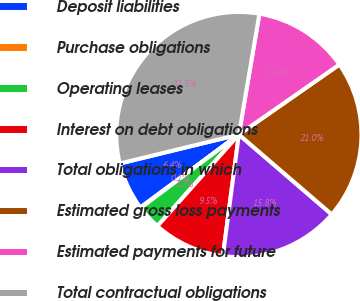Convert chart. <chart><loc_0><loc_0><loc_500><loc_500><pie_chart><fcel>Deposit liabilities<fcel>Purchase obligations<fcel>Operating leases<fcel>Interest on debt obligations<fcel>Total obligations in which<fcel>Estimated gross loss payments<fcel>Estimated payments for future<fcel>Total contractual obligations<nl><fcel>6.35%<fcel>0.07%<fcel>3.21%<fcel>9.49%<fcel>15.78%<fcel>20.98%<fcel>12.64%<fcel>31.48%<nl></chart> 